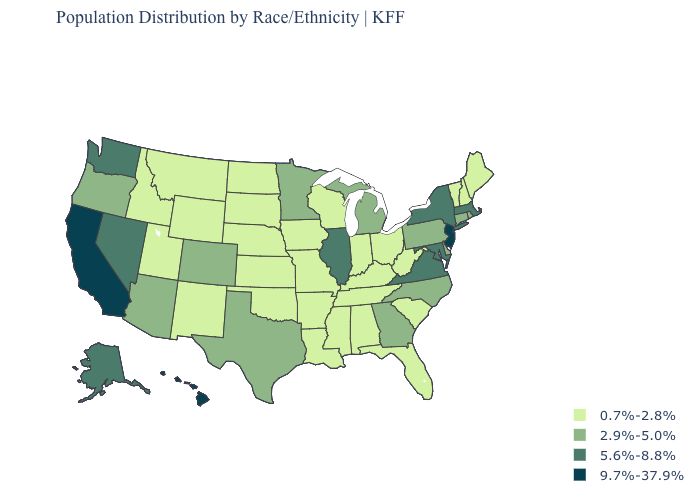Does Kansas have the highest value in the MidWest?
Quick response, please. No. What is the value of Wyoming?
Concise answer only. 0.7%-2.8%. What is the lowest value in states that border Iowa?
Short answer required. 0.7%-2.8%. Name the states that have a value in the range 2.9%-5.0%?
Concise answer only. Arizona, Colorado, Connecticut, Delaware, Georgia, Michigan, Minnesota, North Carolina, Oregon, Pennsylvania, Rhode Island, Texas. Name the states that have a value in the range 2.9%-5.0%?
Concise answer only. Arizona, Colorado, Connecticut, Delaware, Georgia, Michigan, Minnesota, North Carolina, Oregon, Pennsylvania, Rhode Island, Texas. Name the states that have a value in the range 2.9%-5.0%?
Answer briefly. Arizona, Colorado, Connecticut, Delaware, Georgia, Michigan, Minnesota, North Carolina, Oregon, Pennsylvania, Rhode Island, Texas. Name the states that have a value in the range 5.6%-8.8%?
Quick response, please. Alaska, Illinois, Maryland, Massachusetts, Nevada, New York, Virginia, Washington. What is the value of Idaho?
Write a very short answer. 0.7%-2.8%. Name the states that have a value in the range 9.7%-37.9%?
Quick response, please. California, Hawaii, New Jersey. Among the states that border North Carolina , does Tennessee have the lowest value?
Write a very short answer. Yes. Name the states that have a value in the range 2.9%-5.0%?
Quick response, please. Arizona, Colorado, Connecticut, Delaware, Georgia, Michigan, Minnesota, North Carolina, Oregon, Pennsylvania, Rhode Island, Texas. Which states hav the highest value in the South?
Give a very brief answer. Maryland, Virginia. What is the value of Iowa?
Concise answer only. 0.7%-2.8%. Name the states that have a value in the range 5.6%-8.8%?
Answer briefly. Alaska, Illinois, Maryland, Massachusetts, Nevada, New York, Virginia, Washington. 